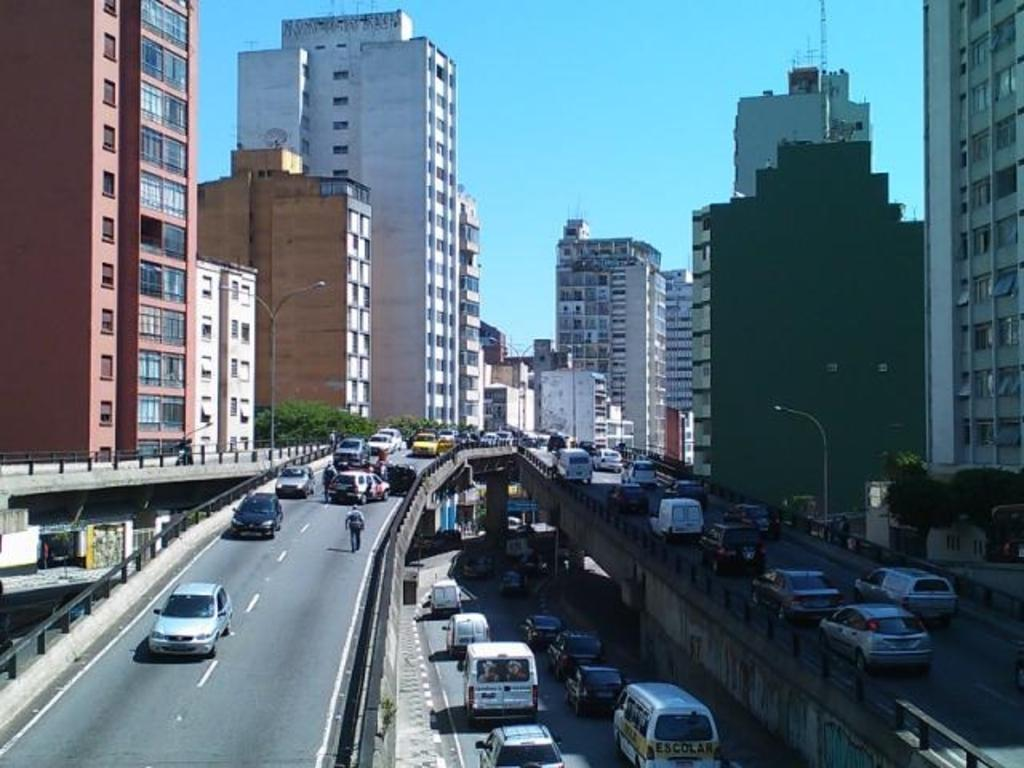What type of structures can be seen in the image? There are many buildings in the image. Where are the buildings located? The buildings are located on roads. Can you describe the distribution of buildings in the image? There are buildings on the left side of the image and on the right side of the image. What is visible at the top of the image? The sky is visible at the top of the image. What is the name of the account associated with the trousers in the image? There are no trousers or accounts present in the image; it features buildings and roads. 